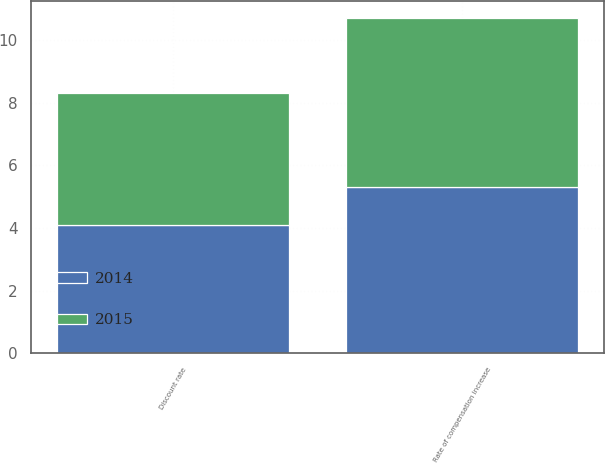Convert chart to OTSL. <chart><loc_0><loc_0><loc_500><loc_500><stacked_bar_chart><ecel><fcel>Discount rate<fcel>Rate of compensation increase<nl><fcel>2015<fcel>4.2<fcel>5.4<nl><fcel>2014<fcel>4.1<fcel>5.3<nl></chart> 